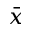<formula> <loc_0><loc_0><loc_500><loc_500>\bar { x }</formula> 